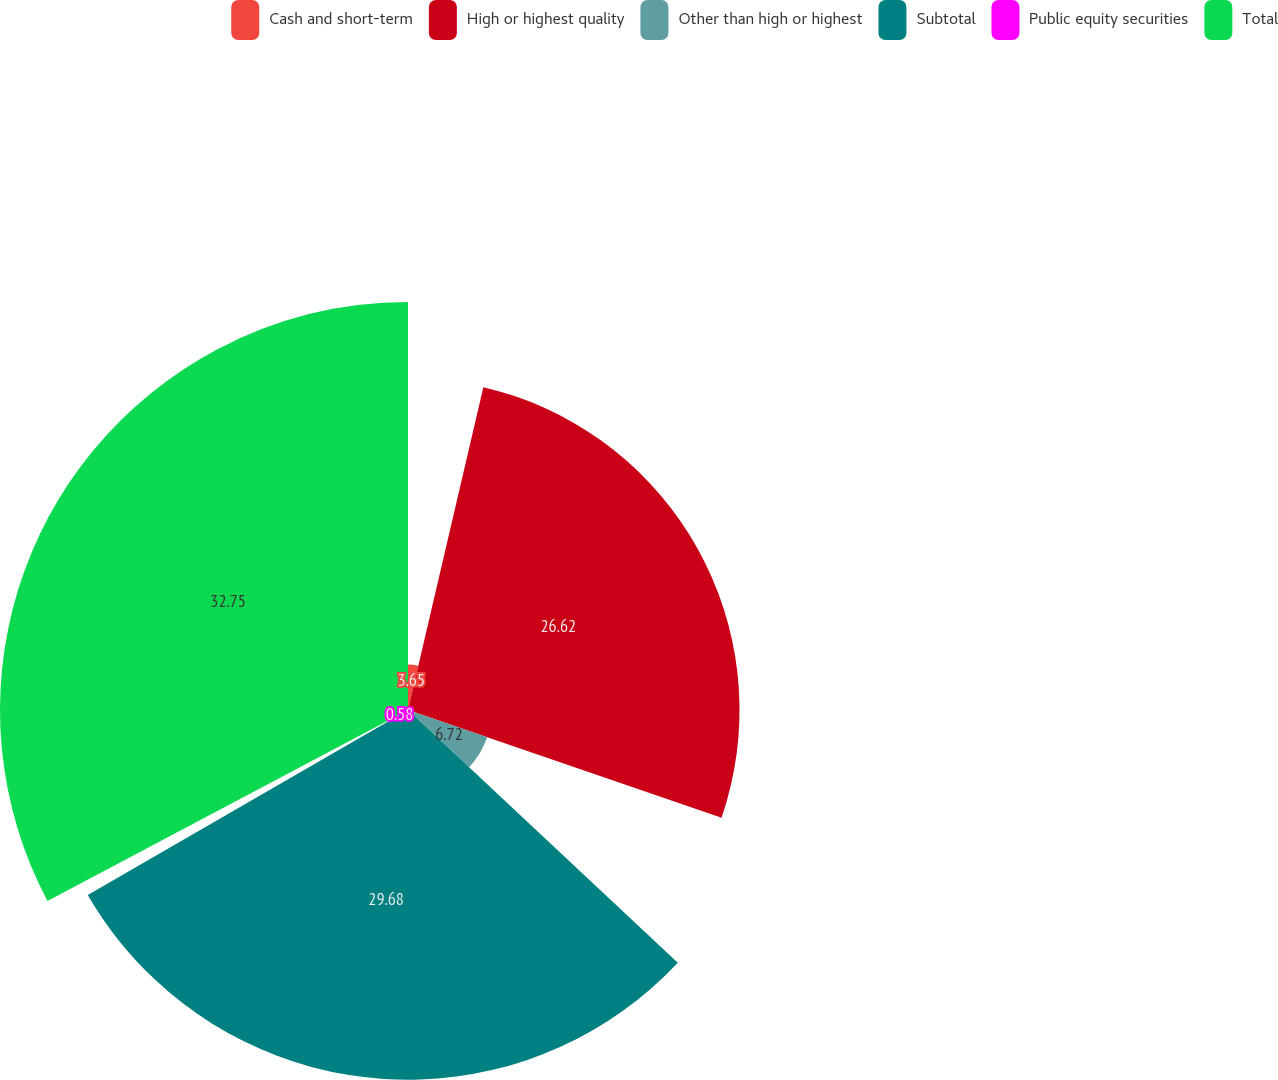Convert chart. <chart><loc_0><loc_0><loc_500><loc_500><pie_chart><fcel>Cash and short-term<fcel>High or highest quality<fcel>Other than high or highest<fcel>Subtotal<fcel>Public equity securities<fcel>Total<nl><fcel>3.65%<fcel>26.62%<fcel>6.72%<fcel>29.69%<fcel>0.58%<fcel>32.76%<nl></chart> 